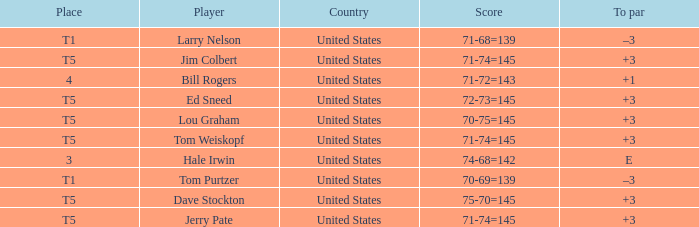What country is player ed sneed, who has a to par of +3, from? United States. Could you help me parse every detail presented in this table? {'header': ['Place', 'Player', 'Country', 'Score', 'To par'], 'rows': [['T1', 'Larry Nelson', 'United States', '71-68=139', '–3'], ['T5', 'Jim Colbert', 'United States', '71-74=145', '+3'], ['4', 'Bill Rogers', 'United States', '71-72=143', '+1'], ['T5', 'Ed Sneed', 'United States', '72-73=145', '+3'], ['T5', 'Lou Graham', 'United States', '70-75=145', '+3'], ['T5', 'Tom Weiskopf', 'United States', '71-74=145', '+3'], ['3', 'Hale Irwin', 'United States', '74-68=142', 'E'], ['T1', 'Tom Purtzer', 'United States', '70-69=139', '–3'], ['T5', 'Dave Stockton', 'United States', '75-70=145', '+3'], ['T5', 'Jerry Pate', 'United States', '71-74=145', '+3']]} 